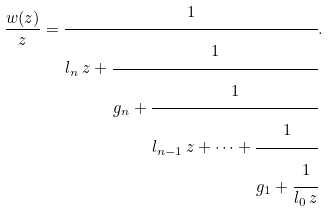Convert formula to latex. <formula><loc_0><loc_0><loc_500><loc_500>\frac { w ( z ) } z = \cfrac { 1 } { l _ { n } \, z + \cfrac { 1 } { g _ { n } + \cfrac { 1 } { l _ { n - 1 } \, z + \dots + \cfrac { 1 } { g _ { 1 } + \cfrac { 1 } { l _ { 0 } \, z } } } } } .</formula> 